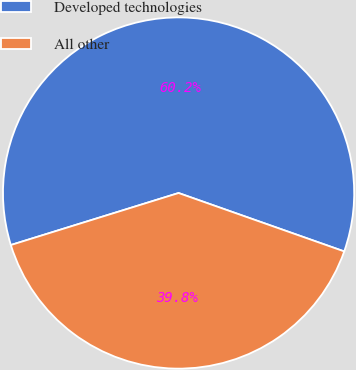<chart> <loc_0><loc_0><loc_500><loc_500><pie_chart><fcel>Developed technologies<fcel>All other<nl><fcel>60.18%<fcel>39.82%<nl></chart> 